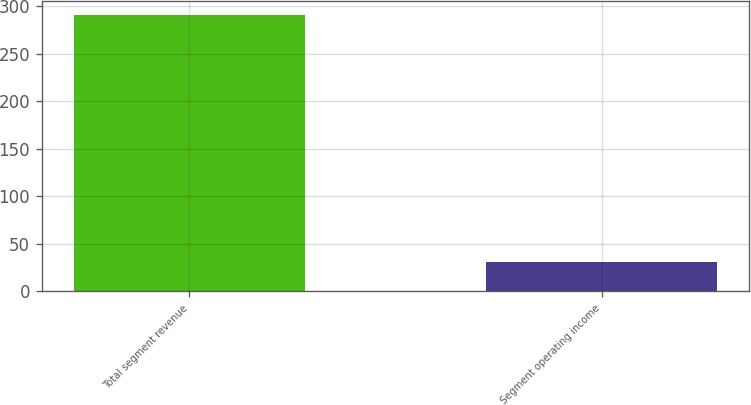Convert chart. <chart><loc_0><loc_0><loc_500><loc_500><bar_chart><fcel>Total segment revenue<fcel>Segment operating income<nl><fcel>291<fcel>31<nl></chart> 